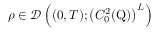<formula> <loc_0><loc_0><loc_500><loc_500>\rho \in \mathcal { D } \left ( ( 0 , T ) ; \left ( C _ { 0 } ^ { 2 } ( Q ) \right ) ^ { L } \right )</formula> 